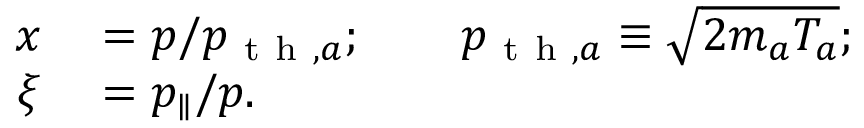Convert formula to latex. <formula><loc_0><loc_0><loc_500><loc_500>\begin{array} { r l } { x } & = p / p _ { t h , a } ; \quad p _ { t h , a } \equiv \sqrt { 2 m _ { a } T _ { a } } ; } \\ { \xi } & = p _ { \| } / p . } \end{array}</formula> 